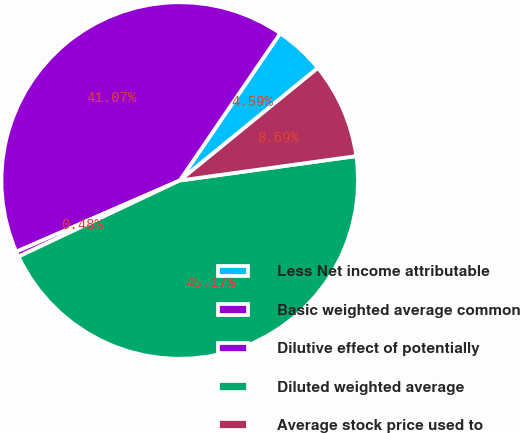<chart> <loc_0><loc_0><loc_500><loc_500><pie_chart><fcel>Less Net income attributable<fcel>Basic weighted average common<fcel>Dilutive effect of potentially<fcel>Diluted weighted average<fcel>Average stock price used to<nl><fcel>4.59%<fcel>41.07%<fcel>0.48%<fcel>45.17%<fcel>8.69%<nl></chart> 